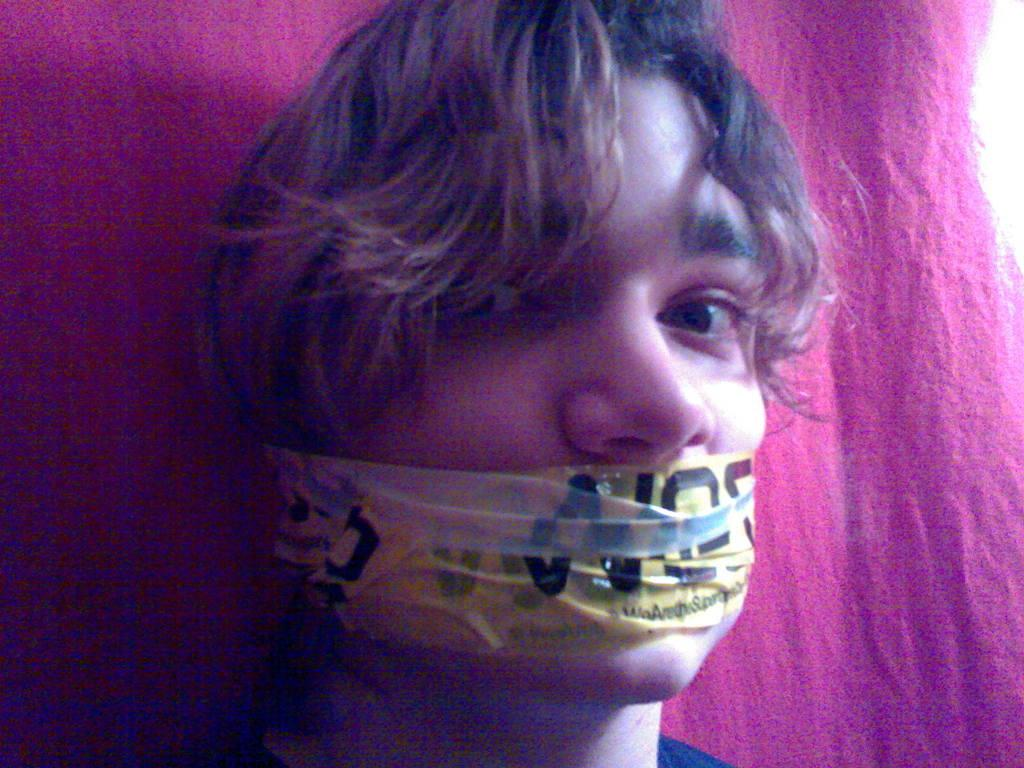What is present in the image? There is a person in the image. What can be seen in the background of the image? There is a cloth in the background of the image. What is unusual about the person's appearance in the image? The person has tape on their mouth. What is the weight of the fan in the image? There is no fan present in the image. 